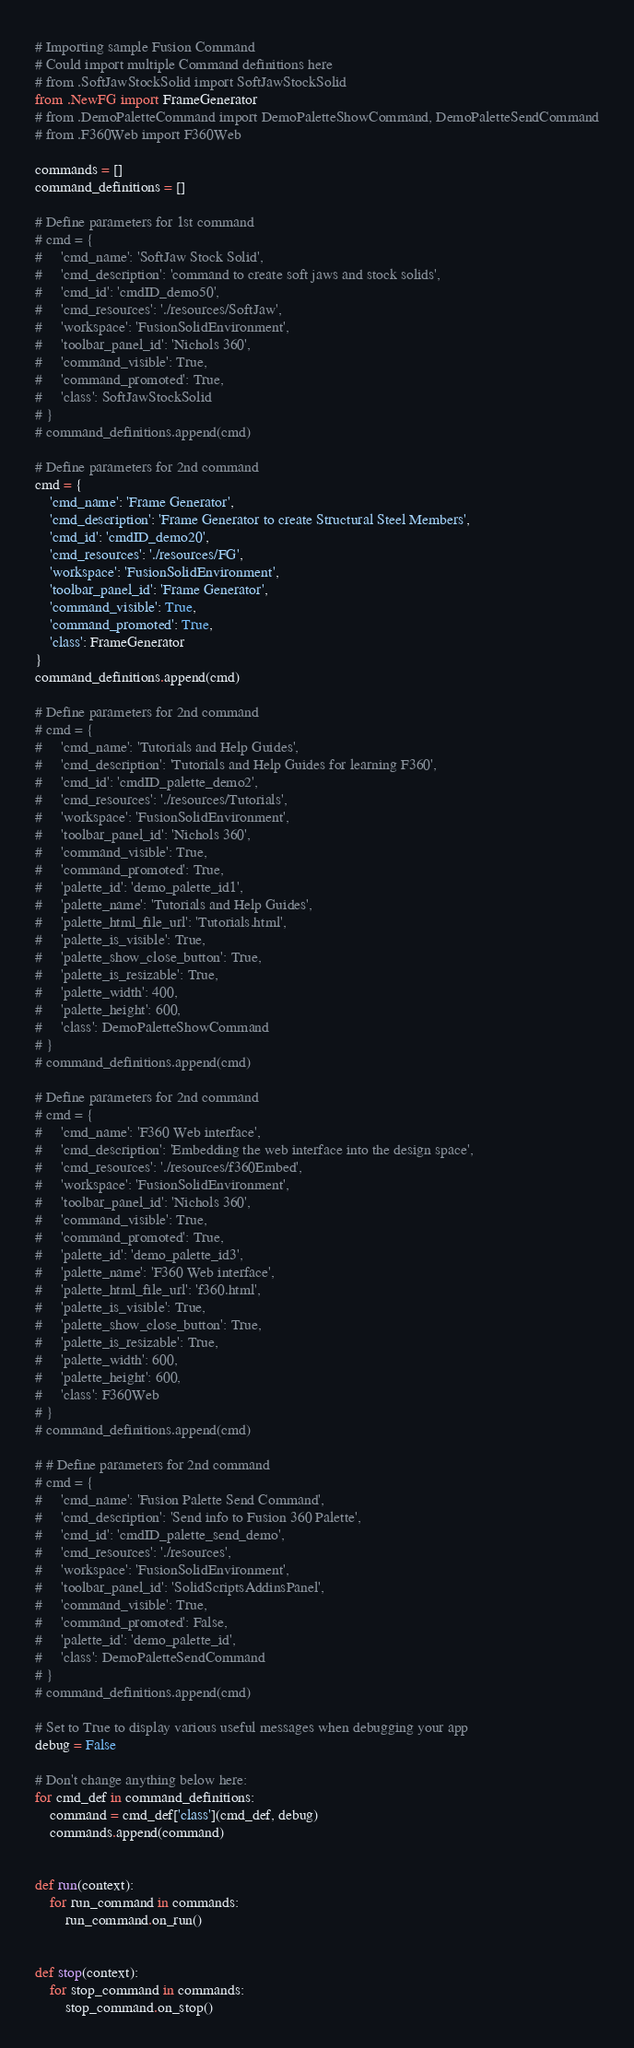Convert code to text. <code><loc_0><loc_0><loc_500><loc_500><_Python_># Importing sample Fusion Command
# Could import multiple Command definitions here
# from .SoftJawStockSolid import SoftJawStockSolid
from .NewFG import FrameGenerator
# from .DemoPaletteCommand import DemoPaletteShowCommand, DemoPaletteSendCommand
# from .F360Web import F360Web

commands = []
command_definitions = []

# Define parameters for 1st command
# cmd = {
#     'cmd_name': 'SoftJaw Stock Solid',
#     'cmd_description': 'command to create soft jaws and stock solids',
#     'cmd_id': 'cmdID_demo50',
#     'cmd_resources': './resources/SoftJaw',
#     'workspace': 'FusionSolidEnvironment',
#     'toolbar_panel_id': 'Nichols 360',
#     'command_visible': True,
#     'command_promoted': True,
#     'class': SoftJawStockSolid
# }
# command_definitions.append(cmd)

# Define parameters for 2nd command
cmd = {
    'cmd_name': 'Frame Generator',
    'cmd_description': 'Frame Generator to create Structural Steel Members',
    'cmd_id': 'cmdID_demo20',
    'cmd_resources': './resources/FG',
    'workspace': 'FusionSolidEnvironment',
    'toolbar_panel_id': 'Frame Generator',
    'command_visible': True,
    'command_promoted': True,
    'class': FrameGenerator
}
command_definitions.append(cmd)

# Define parameters for 2nd command
# cmd = {
#     'cmd_name': 'Tutorials and Help Guides',
#     'cmd_description': 'Tutorials and Help Guides for learning F360',
#     'cmd_id': 'cmdID_palette_demo2',
#     'cmd_resources': './resources/Tutorials',
#     'workspace': 'FusionSolidEnvironment',
#     'toolbar_panel_id': 'Nichols 360',
#     'command_visible': True,
#     'command_promoted': True,
#     'palette_id': 'demo_palette_id1',
#     'palette_name': 'Tutorials and Help Guides',
#     'palette_html_file_url': 'Tutorials.html',
#     'palette_is_visible': True,
#     'palette_show_close_button': True,
#     'palette_is_resizable': True,
#     'palette_width': 400,
#     'palette_height': 600,
#     'class': DemoPaletteShowCommand
# }
# command_definitions.append(cmd)

# Define parameters for 2nd command
# cmd = {
#     'cmd_name': 'F360 Web interface',
#     'cmd_description': 'Embedding the web interface into the design space',
#     'cmd_resources': './resources/f360Embed',
#     'workspace': 'FusionSolidEnvironment',
#     'toolbar_panel_id': 'Nichols 360',
#     'command_visible': True,
#     'command_promoted': True,
#     'palette_id': 'demo_palette_id3',
#     'palette_name': 'F360 Web interface',
#     'palette_html_file_url': 'f360.html',
#     'palette_is_visible': True,
#     'palette_show_close_button': True,
#     'palette_is_resizable': True,
#     'palette_width': 600,
#     'palette_height': 600,
#     'class': F360Web
# }
# command_definitions.append(cmd)

# # Define parameters for 2nd command
# cmd = {
#     'cmd_name': 'Fusion Palette Send Command',
#     'cmd_description': 'Send info to Fusion 360 Palette',
#     'cmd_id': 'cmdID_palette_send_demo',
#     'cmd_resources': './resources',
#     'workspace': 'FusionSolidEnvironment',
#     'toolbar_panel_id': 'SolidScriptsAddinsPanel',
#     'command_visible': True,
#     'command_promoted': False,
#     'palette_id': 'demo_palette_id',
#     'class': DemoPaletteSendCommand
# }
# command_definitions.append(cmd)

# Set to True to display various useful messages when debugging your app
debug = False

# Don't change anything below here:
for cmd_def in command_definitions:
    command = cmd_def['class'](cmd_def, debug)
    commands.append(command)


def run(context):
    for run_command in commands:
        run_command.on_run()


def stop(context):
    for stop_command in commands:
        stop_command.on_stop()
</code> 